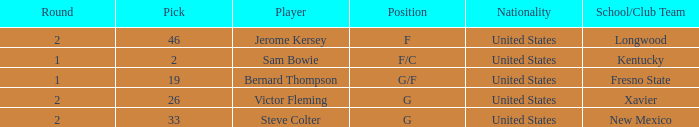What is Nationality, when Position is "G", and when Pick is greater than 26? United States. 